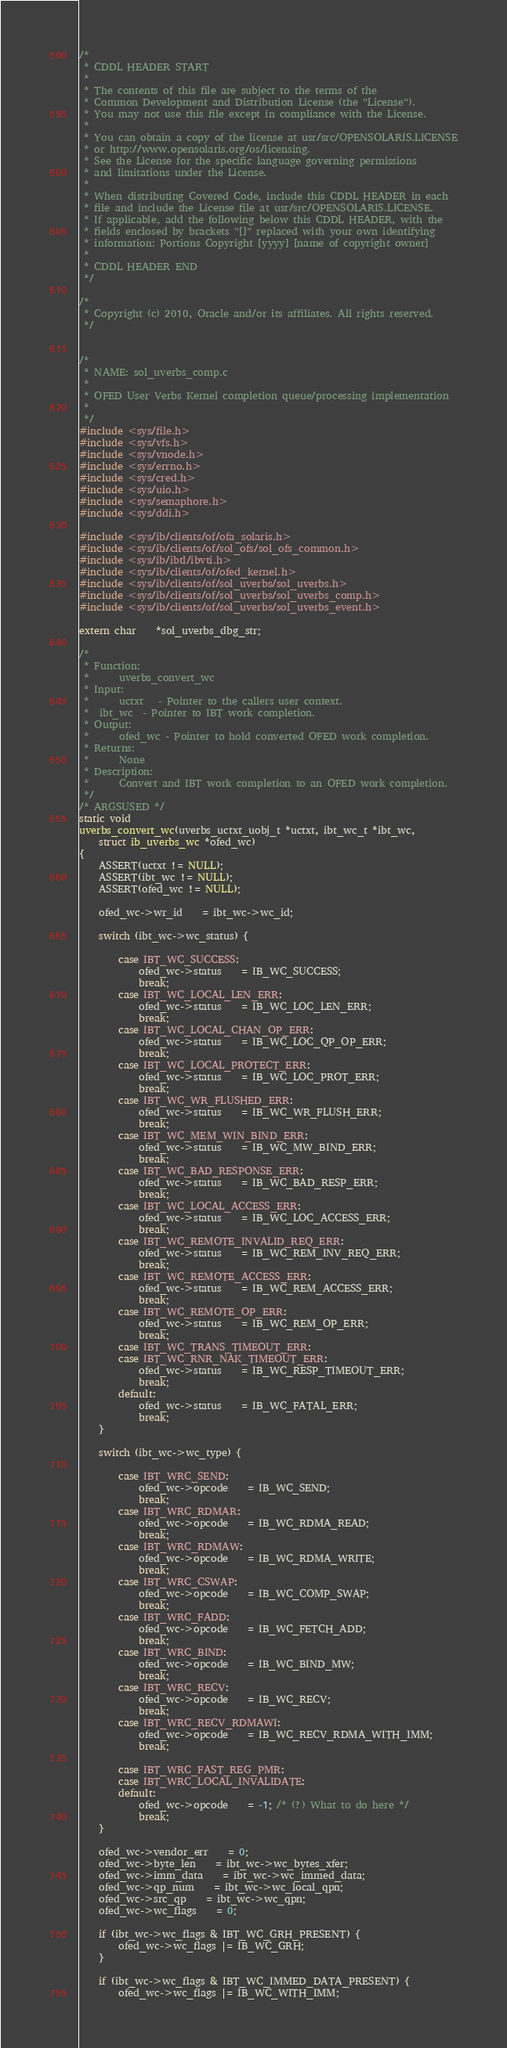Convert code to text. <code><loc_0><loc_0><loc_500><loc_500><_C_>/*
 * CDDL HEADER START
 *
 * The contents of this file are subject to the terms of the
 * Common Development and Distribution License (the "License").
 * You may not use this file except in compliance with the License.
 *
 * You can obtain a copy of the license at usr/src/OPENSOLARIS.LICENSE
 * or http://www.opensolaris.org/os/licensing.
 * See the License for the specific language governing permissions
 * and limitations under the License.
 *
 * When distributing Covered Code, include this CDDL HEADER in each
 * file and include the License file at usr/src/OPENSOLARIS.LICENSE.
 * If applicable, add the following below this CDDL HEADER, with the
 * fields enclosed by brackets "[]" replaced with your own identifying
 * information: Portions Copyright [yyyy] [name of copyright owner]
 *
 * CDDL HEADER END
 */

/*
 * Copyright (c) 2010, Oracle and/or its affiliates. All rights reserved.
 */


/*
 * NAME: sol_uverbs_comp.c
 *
 * OFED User Verbs Kernel completion queue/processing implementation
 *
 */
#include <sys/file.h>
#include <sys/vfs.h>
#include <sys/vnode.h>
#include <sys/errno.h>
#include <sys/cred.h>
#include <sys/uio.h>
#include <sys/semaphore.h>
#include <sys/ddi.h>

#include <sys/ib/clients/of/ofa_solaris.h>
#include <sys/ib/clients/of/sol_ofs/sol_ofs_common.h>
#include <sys/ib/ibtl/ibvti.h>
#include <sys/ib/clients/of/ofed_kernel.h>
#include <sys/ib/clients/of/sol_uverbs/sol_uverbs.h>
#include <sys/ib/clients/of/sol_uverbs/sol_uverbs_comp.h>
#include <sys/ib/clients/of/sol_uverbs/sol_uverbs_event.h>

extern char	*sol_uverbs_dbg_str;

/*
 * Function:
 *      uverbs_convert_wc
 * Input:
 *      uctxt	- Pointer to the callers user context.
 *	ibt_wc	- Pointer to IBT work completion.
 * Output:
 *      ofed_wc	- Pointer to hold converted OFED work completion.
 * Returns:
 *      None
 * Description:
 *      Convert and IBT work completion to an OFED work completion.
 */
/* ARGSUSED */
static void
uverbs_convert_wc(uverbs_uctxt_uobj_t *uctxt, ibt_wc_t *ibt_wc,
    struct ib_uverbs_wc *ofed_wc)
{
	ASSERT(uctxt != NULL);
	ASSERT(ibt_wc != NULL);
	ASSERT(ofed_wc != NULL);

	ofed_wc->wr_id	= ibt_wc->wc_id;

	switch (ibt_wc->wc_status) {

		case IBT_WC_SUCCESS:
			ofed_wc->status	= IB_WC_SUCCESS;
			break;
		case IBT_WC_LOCAL_LEN_ERR:
			ofed_wc->status	= IB_WC_LOC_LEN_ERR;
			break;
		case IBT_WC_LOCAL_CHAN_OP_ERR:
			ofed_wc->status	= IB_WC_LOC_QP_OP_ERR;
			break;
		case IBT_WC_LOCAL_PROTECT_ERR:
			ofed_wc->status	= IB_WC_LOC_PROT_ERR;
			break;
		case IBT_WC_WR_FLUSHED_ERR:
			ofed_wc->status	= IB_WC_WR_FLUSH_ERR;
			break;
		case IBT_WC_MEM_WIN_BIND_ERR:
			ofed_wc->status	= IB_WC_MW_BIND_ERR;
			break;
		case IBT_WC_BAD_RESPONSE_ERR:
			ofed_wc->status	= IB_WC_BAD_RESP_ERR;
			break;
		case IBT_WC_LOCAL_ACCESS_ERR:
			ofed_wc->status	= IB_WC_LOC_ACCESS_ERR;
			break;
		case IBT_WC_REMOTE_INVALID_REQ_ERR:
			ofed_wc->status	= IB_WC_REM_INV_REQ_ERR;
			break;
		case IBT_WC_REMOTE_ACCESS_ERR:
			ofed_wc->status	= IB_WC_REM_ACCESS_ERR;
			break;
		case IBT_WC_REMOTE_OP_ERR:
			ofed_wc->status	= IB_WC_REM_OP_ERR;
			break;
		case IBT_WC_TRANS_TIMEOUT_ERR:
		case IBT_WC_RNR_NAK_TIMEOUT_ERR:
			ofed_wc->status	= IB_WC_RESP_TIMEOUT_ERR;
			break;
		default:
			ofed_wc->status	= IB_WC_FATAL_ERR;
			break;
	}

	switch (ibt_wc->wc_type) {

		case IBT_WRC_SEND:
			ofed_wc->opcode	= IB_WC_SEND;
			break;
		case IBT_WRC_RDMAR:
			ofed_wc->opcode	= IB_WC_RDMA_READ;
			break;
		case IBT_WRC_RDMAW:
			ofed_wc->opcode	= IB_WC_RDMA_WRITE;
			break;
		case IBT_WRC_CSWAP:
			ofed_wc->opcode	= IB_WC_COMP_SWAP;
			break;
		case IBT_WRC_FADD:
			ofed_wc->opcode	= IB_WC_FETCH_ADD;
			break;
		case IBT_WRC_BIND:
			ofed_wc->opcode	= IB_WC_BIND_MW;
			break;
		case IBT_WRC_RECV:
			ofed_wc->opcode	= IB_WC_RECV;
			break;
		case IBT_WRC_RECV_RDMAWI:
			ofed_wc->opcode	= IB_WC_RECV_RDMA_WITH_IMM;
			break;

		case IBT_WRC_FAST_REG_PMR:
		case IBT_WRC_LOCAL_INVALIDATE:
		default:
			ofed_wc->opcode	= -1; /* (?) What to do here */
			break;
	}

	ofed_wc->vendor_err 	= 0;
	ofed_wc->byte_len 	= ibt_wc->wc_bytes_xfer;
	ofed_wc->imm_data 	= ibt_wc->wc_immed_data;
	ofed_wc->qp_num 	= ibt_wc->wc_local_qpn;
	ofed_wc->src_qp 	= ibt_wc->wc_qpn;
	ofed_wc->wc_flags	= 0;

	if (ibt_wc->wc_flags & IBT_WC_GRH_PRESENT) {
		ofed_wc->wc_flags |= IB_WC_GRH;
	}

	if (ibt_wc->wc_flags & IBT_WC_IMMED_DATA_PRESENT) {
		ofed_wc->wc_flags |= IB_WC_WITH_IMM;</code> 